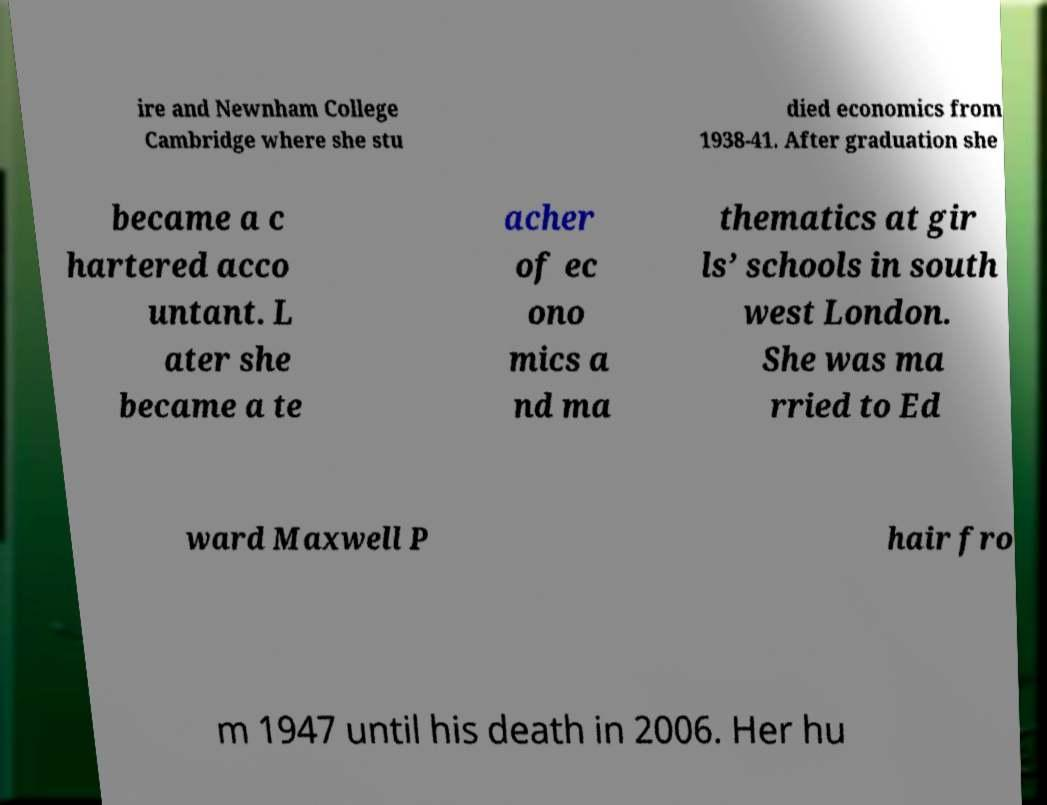What messages or text are displayed in this image? I need them in a readable, typed format. ire and Newnham College Cambridge where she stu died economics from 1938-41. After graduation she became a c hartered acco untant. L ater she became a te acher of ec ono mics a nd ma thematics at gir ls’ schools in south west London. She was ma rried to Ed ward Maxwell P hair fro m 1947 until his death in 2006. Her hu 